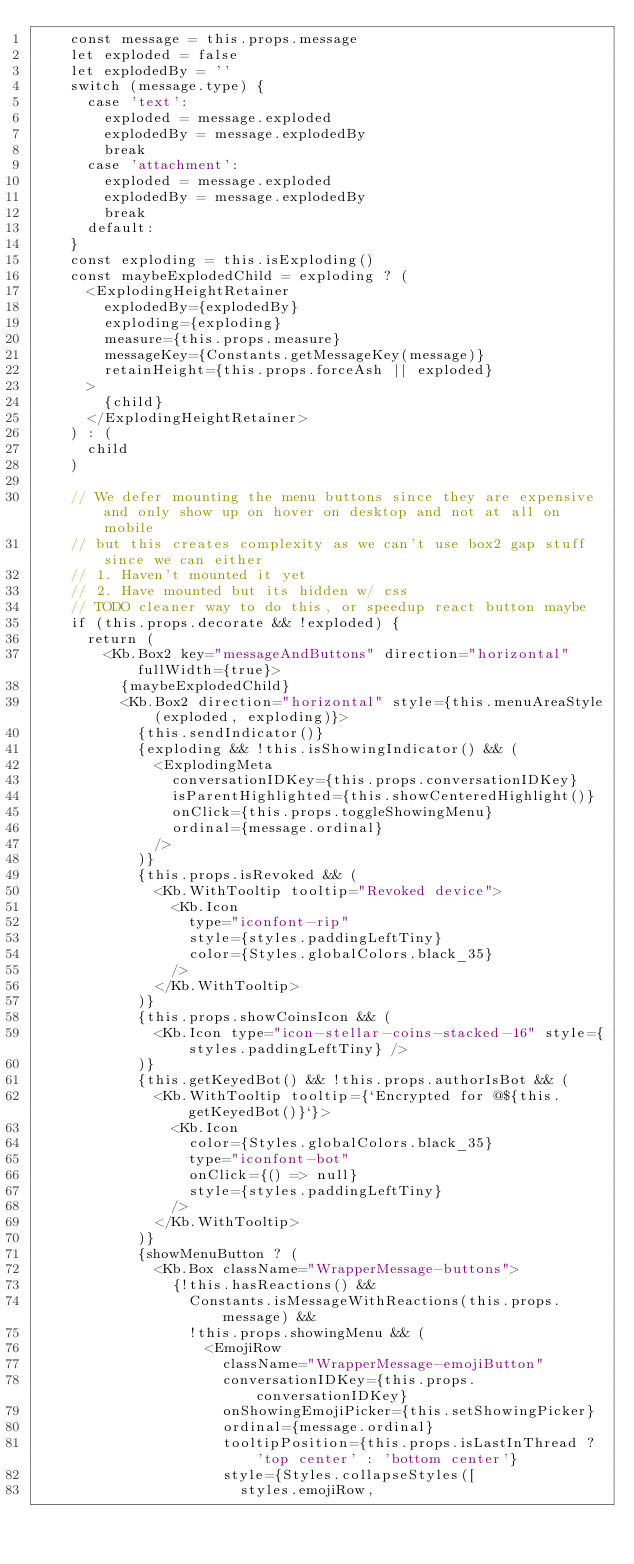Convert code to text. <code><loc_0><loc_0><loc_500><loc_500><_TypeScript_>    const message = this.props.message
    let exploded = false
    let explodedBy = ''
    switch (message.type) {
      case 'text':
        exploded = message.exploded
        explodedBy = message.explodedBy
        break
      case 'attachment':
        exploded = message.exploded
        explodedBy = message.explodedBy
        break
      default:
    }
    const exploding = this.isExploding()
    const maybeExplodedChild = exploding ? (
      <ExplodingHeightRetainer
        explodedBy={explodedBy}
        exploding={exploding}
        measure={this.props.measure}
        messageKey={Constants.getMessageKey(message)}
        retainHeight={this.props.forceAsh || exploded}
      >
        {child}
      </ExplodingHeightRetainer>
    ) : (
      child
    )

    // We defer mounting the menu buttons since they are expensive and only show up on hover on desktop and not at all on mobile
    // but this creates complexity as we can't use box2 gap stuff since we can either
    // 1. Haven't mounted it yet
    // 2. Have mounted but its hidden w/ css
    // TODO cleaner way to do this, or speedup react button maybe
    if (this.props.decorate && !exploded) {
      return (
        <Kb.Box2 key="messageAndButtons" direction="horizontal" fullWidth={true}>
          {maybeExplodedChild}
          <Kb.Box2 direction="horizontal" style={this.menuAreaStyle(exploded, exploding)}>
            {this.sendIndicator()}
            {exploding && !this.isShowingIndicator() && (
              <ExplodingMeta
                conversationIDKey={this.props.conversationIDKey}
                isParentHighlighted={this.showCenteredHighlight()}
                onClick={this.props.toggleShowingMenu}
                ordinal={message.ordinal}
              />
            )}
            {this.props.isRevoked && (
              <Kb.WithTooltip tooltip="Revoked device">
                <Kb.Icon
                  type="iconfont-rip"
                  style={styles.paddingLeftTiny}
                  color={Styles.globalColors.black_35}
                />
              </Kb.WithTooltip>
            )}
            {this.props.showCoinsIcon && (
              <Kb.Icon type="icon-stellar-coins-stacked-16" style={styles.paddingLeftTiny} />
            )}
            {this.getKeyedBot() && !this.props.authorIsBot && (
              <Kb.WithTooltip tooltip={`Encrypted for @${this.getKeyedBot()}`}>
                <Kb.Icon
                  color={Styles.globalColors.black_35}
                  type="iconfont-bot"
                  onClick={() => null}
                  style={styles.paddingLeftTiny}
                />
              </Kb.WithTooltip>
            )}
            {showMenuButton ? (
              <Kb.Box className="WrapperMessage-buttons">
                {!this.hasReactions() &&
                  Constants.isMessageWithReactions(this.props.message) &&
                  !this.props.showingMenu && (
                    <EmojiRow
                      className="WrapperMessage-emojiButton"
                      conversationIDKey={this.props.conversationIDKey}
                      onShowingEmojiPicker={this.setShowingPicker}
                      ordinal={message.ordinal}
                      tooltipPosition={this.props.isLastInThread ? 'top center' : 'bottom center'}
                      style={Styles.collapseStyles([
                        styles.emojiRow,</code> 